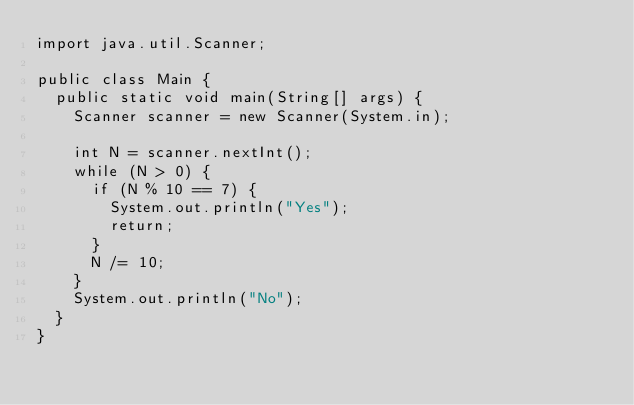<code> <loc_0><loc_0><loc_500><loc_500><_Java_>import java.util.Scanner;

public class Main {
  public static void main(String[] args) {
    Scanner scanner = new Scanner(System.in);

    int N = scanner.nextInt();
    while (N > 0) {
      if (N % 10 == 7) {
        System.out.println("Yes");
        return;
      }
      N /= 10;
    }
    System.out.println("No");
  }
}
</code> 